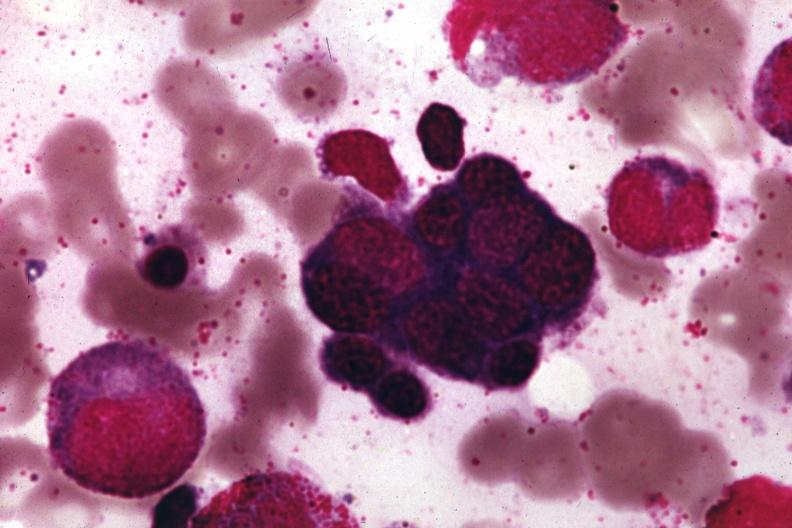does capillary show wrights?
Answer the question using a single word or phrase. No 